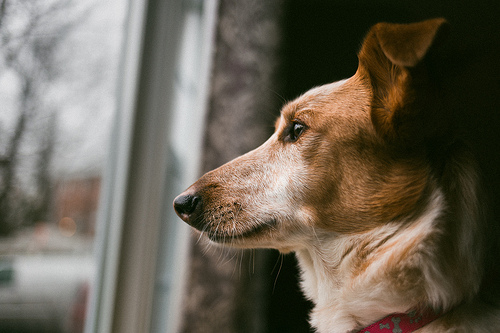<image>
Can you confirm if the dog is to the right of the window? Yes. From this viewpoint, the dog is positioned to the right side relative to the window. Where is the cat in relation to the snow? Is it next to the snow? No. The cat is not positioned next to the snow. They are located in different areas of the scene. Is the dog in front of the window? Yes. The dog is positioned in front of the window, appearing closer to the camera viewpoint. 